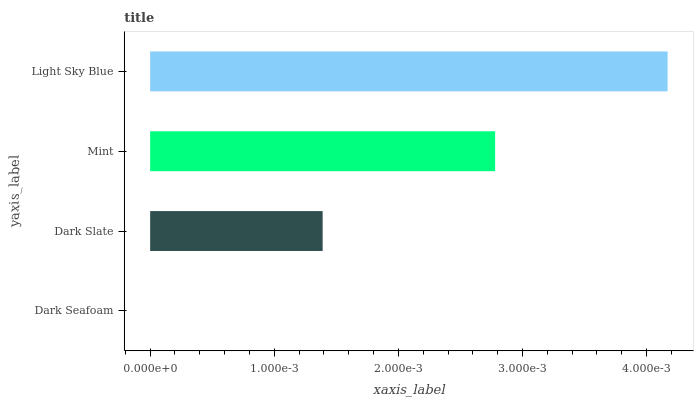Is Dark Seafoam the minimum?
Answer yes or no. Yes. Is Light Sky Blue the maximum?
Answer yes or no. Yes. Is Dark Slate the minimum?
Answer yes or no. No. Is Dark Slate the maximum?
Answer yes or no. No. Is Dark Slate greater than Dark Seafoam?
Answer yes or no. Yes. Is Dark Seafoam less than Dark Slate?
Answer yes or no. Yes. Is Dark Seafoam greater than Dark Slate?
Answer yes or no. No. Is Dark Slate less than Dark Seafoam?
Answer yes or no. No. Is Mint the high median?
Answer yes or no. Yes. Is Dark Slate the low median?
Answer yes or no. Yes. Is Dark Seafoam the high median?
Answer yes or no. No. Is Light Sky Blue the low median?
Answer yes or no. No. 